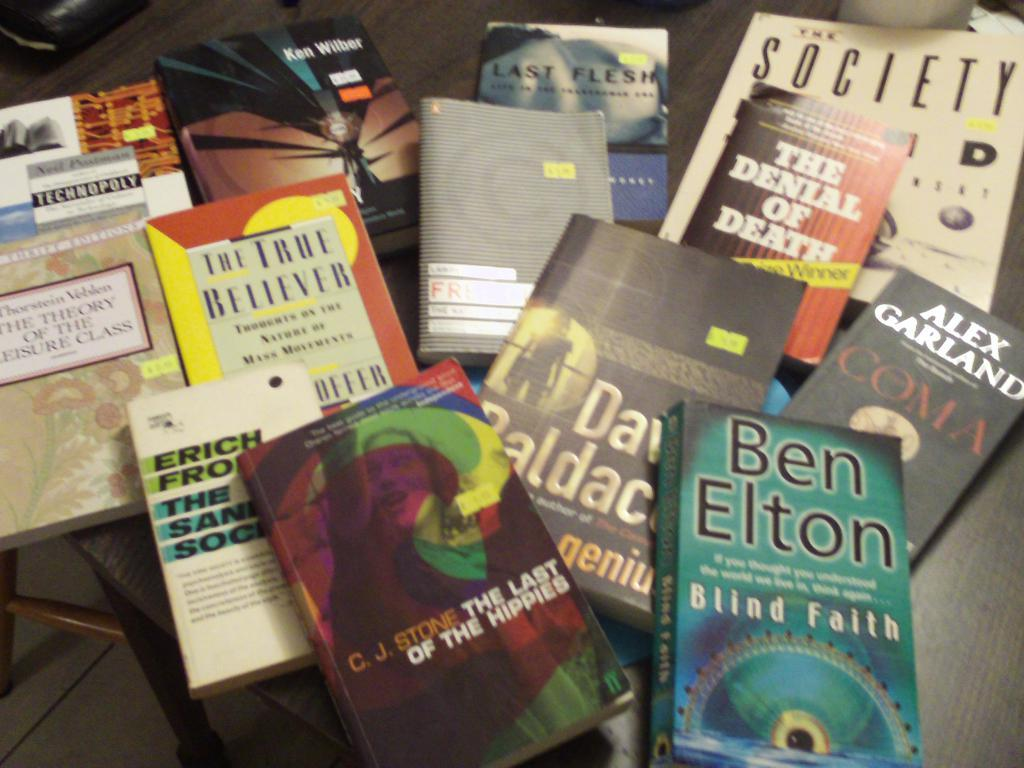Provide a one-sentence caption for the provided image. Several books on a table one is called The denial of death. 